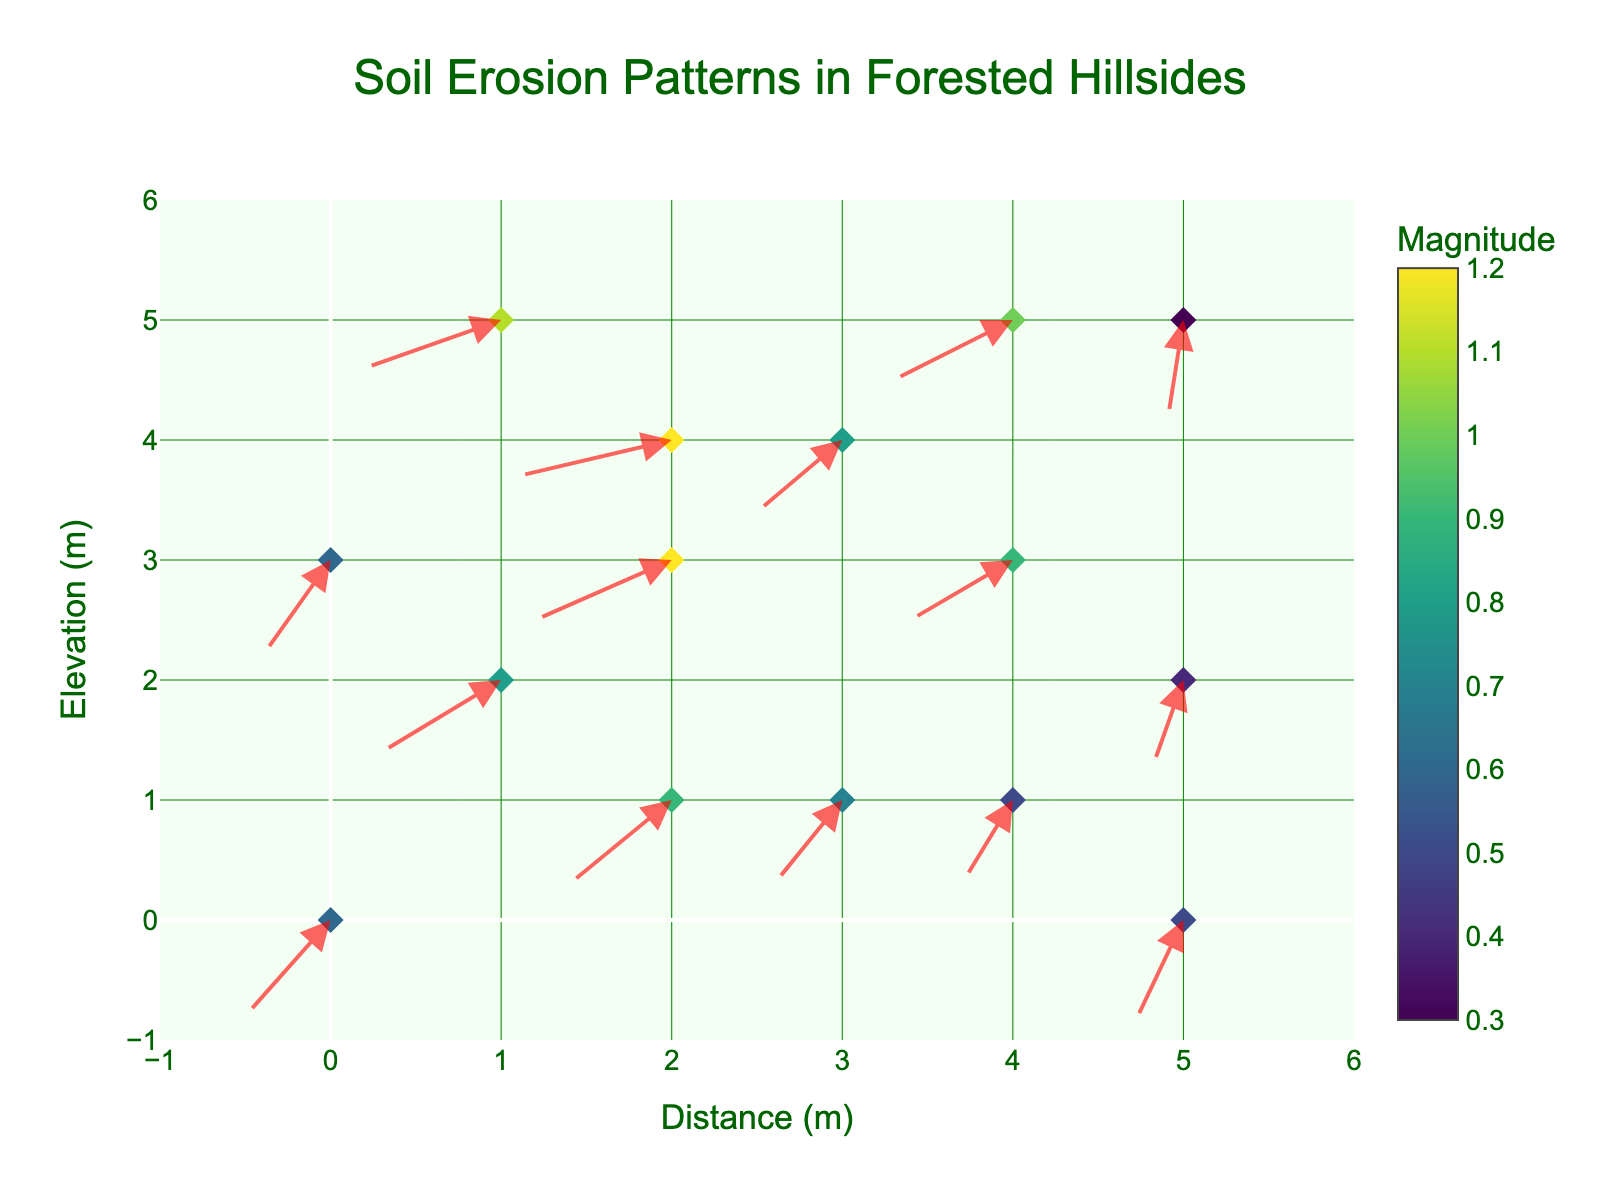What does the title of the plot indicate? The title of the plot is "Soil Erosion Patterns in Forested Hillsides," which indicates that the plot visualizes how soil erosion patterns develop on forested hillsides after rainfall.
Answer: Soil Erosion Patterns in Forested Hillsides What are the units used for the x and y axes? The x-axis is labeled "Distance (m)," implying that distances are measured in meters. The y-axis is labeled "Elevation (m)," suggesting that elevations are also measured in meters.
Answer: meters How many data points are mapped on the plot? By counting each arrow or marker on the plot, we can determine the number of data points visualized. There are 15 data points on the plot.
Answer: 15 Which data point has the highest magnitude? To identify the highest magnitude, we need to look for the highest value indicated in the color legend or hover text. The data point at coordinates (2, 4) has the highest magnitude of 1.2.
Answer: (2, 4) Which direction do most of the arrows point? By examining the majority of the arrows, we see that most of them point generally downwards, indicating the direction of sediment transport.
Answer: Downwards Compare the magnitudes of the data points at (5, 5) and (4, 3). Which one is greater? The magnitude is indicated on the marker color and corresponding hover text. For the points (5, 5) and (4, 3), the magnitudes are 0.3 and 0.9, respectively. Therefore, the magnitude at (4, 3) is greater.
Answer: (4, 3) What is the average magnitude of the data points at elevations higher than 3 meters? There are data points at (x, y): (1, 5), (4, 5), and (0, 3). Their magnitudes are 1.1, 1.0, and 0.6. The average magnitude is (1.1 + 1.0 + 0.6)/3, which is approximately 0.9.
Answer: 0.9 Are there any data points where the sediment is being transported primarily horizontally? By examining the arrows, we can see that most components are vertical. However, by looking at the horizontal (u) and vertical (v) components, none of the arrows have a u-component significantly greater than the v-component, indicating that there are no primary horizontal transports.
Answer: No Which location has the steepest slope of sediment transport, based on the arrows? The steepness is indicated by the magnitude of the vectors. The coordinates with the highest magnitude (1.2) is at (2,4) and (2,3), indicating the steepest slope based on these magnitudes.
Answer: (2, 4) and (2, 3) What is the magnitude range shown by the color scale? The color scale legend indicates the variation in magnitude from the dataset. The range spans from the minimum value of 0.3 to the maximum value of 1.2.
Answer: 0.3 to 1.2 